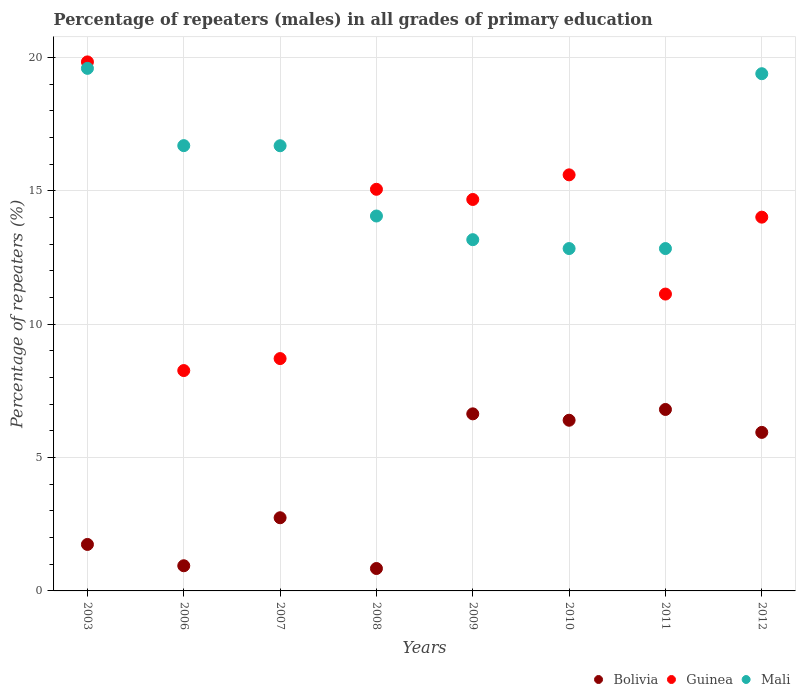Is the number of dotlines equal to the number of legend labels?
Keep it short and to the point. Yes. What is the percentage of repeaters (males) in Mali in 2009?
Offer a terse response. 13.17. Across all years, what is the maximum percentage of repeaters (males) in Guinea?
Make the answer very short. 19.84. Across all years, what is the minimum percentage of repeaters (males) in Guinea?
Give a very brief answer. 8.26. What is the total percentage of repeaters (males) in Bolivia in the graph?
Make the answer very short. 32.06. What is the difference between the percentage of repeaters (males) in Bolivia in 2006 and that in 2008?
Offer a terse response. 0.1. What is the difference between the percentage of repeaters (males) in Guinea in 2007 and the percentage of repeaters (males) in Bolivia in 2010?
Give a very brief answer. 2.31. What is the average percentage of repeaters (males) in Bolivia per year?
Ensure brevity in your answer.  4.01. In the year 2007, what is the difference between the percentage of repeaters (males) in Bolivia and percentage of repeaters (males) in Guinea?
Your answer should be very brief. -5.97. In how many years, is the percentage of repeaters (males) in Bolivia greater than 4 %?
Your response must be concise. 4. What is the ratio of the percentage of repeaters (males) in Guinea in 2007 to that in 2012?
Offer a terse response. 0.62. Is the percentage of repeaters (males) in Guinea in 2009 less than that in 2010?
Ensure brevity in your answer.  Yes. What is the difference between the highest and the second highest percentage of repeaters (males) in Bolivia?
Ensure brevity in your answer.  0.16. What is the difference between the highest and the lowest percentage of repeaters (males) in Bolivia?
Your response must be concise. 5.96. Is the percentage of repeaters (males) in Mali strictly greater than the percentage of repeaters (males) in Bolivia over the years?
Provide a short and direct response. Yes. Is the percentage of repeaters (males) in Mali strictly less than the percentage of repeaters (males) in Guinea over the years?
Give a very brief answer. No. Are the values on the major ticks of Y-axis written in scientific E-notation?
Your response must be concise. No. Does the graph contain grids?
Your answer should be compact. Yes. How many legend labels are there?
Provide a succinct answer. 3. What is the title of the graph?
Provide a short and direct response. Percentage of repeaters (males) in all grades of primary education. Does "Tajikistan" appear as one of the legend labels in the graph?
Keep it short and to the point. No. What is the label or title of the X-axis?
Give a very brief answer. Years. What is the label or title of the Y-axis?
Offer a very short reply. Percentage of repeaters (%). What is the Percentage of repeaters (%) in Bolivia in 2003?
Your answer should be compact. 1.74. What is the Percentage of repeaters (%) in Guinea in 2003?
Ensure brevity in your answer.  19.84. What is the Percentage of repeaters (%) of Mali in 2003?
Provide a short and direct response. 19.59. What is the Percentage of repeaters (%) in Bolivia in 2006?
Give a very brief answer. 0.94. What is the Percentage of repeaters (%) of Guinea in 2006?
Ensure brevity in your answer.  8.26. What is the Percentage of repeaters (%) of Mali in 2006?
Your answer should be very brief. 16.7. What is the Percentage of repeaters (%) in Bolivia in 2007?
Your answer should be compact. 2.74. What is the Percentage of repeaters (%) in Guinea in 2007?
Offer a very short reply. 8.71. What is the Percentage of repeaters (%) of Mali in 2007?
Your answer should be very brief. 16.69. What is the Percentage of repeaters (%) in Bolivia in 2008?
Give a very brief answer. 0.84. What is the Percentage of repeaters (%) of Guinea in 2008?
Your answer should be very brief. 15.06. What is the Percentage of repeaters (%) of Mali in 2008?
Offer a very short reply. 14.06. What is the Percentage of repeaters (%) of Bolivia in 2009?
Keep it short and to the point. 6.64. What is the Percentage of repeaters (%) of Guinea in 2009?
Offer a terse response. 14.68. What is the Percentage of repeaters (%) in Mali in 2009?
Offer a terse response. 13.17. What is the Percentage of repeaters (%) of Bolivia in 2010?
Provide a short and direct response. 6.4. What is the Percentage of repeaters (%) of Guinea in 2010?
Offer a terse response. 15.6. What is the Percentage of repeaters (%) of Mali in 2010?
Provide a short and direct response. 12.84. What is the Percentage of repeaters (%) in Bolivia in 2011?
Your answer should be compact. 6.8. What is the Percentage of repeaters (%) in Guinea in 2011?
Give a very brief answer. 11.13. What is the Percentage of repeaters (%) in Mali in 2011?
Provide a succinct answer. 12.84. What is the Percentage of repeaters (%) of Bolivia in 2012?
Give a very brief answer. 5.94. What is the Percentage of repeaters (%) of Guinea in 2012?
Provide a short and direct response. 14.01. What is the Percentage of repeaters (%) in Mali in 2012?
Provide a short and direct response. 19.39. Across all years, what is the maximum Percentage of repeaters (%) of Bolivia?
Your answer should be very brief. 6.8. Across all years, what is the maximum Percentage of repeaters (%) in Guinea?
Offer a very short reply. 19.84. Across all years, what is the maximum Percentage of repeaters (%) of Mali?
Offer a terse response. 19.59. Across all years, what is the minimum Percentage of repeaters (%) in Bolivia?
Keep it short and to the point. 0.84. Across all years, what is the minimum Percentage of repeaters (%) of Guinea?
Offer a terse response. 8.26. Across all years, what is the minimum Percentage of repeaters (%) of Mali?
Your response must be concise. 12.84. What is the total Percentage of repeaters (%) in Bolivia in the graph?
Your answer should be compact. 32.06. What is the total Percentage of repeaters (%) of Guinea in the graph?
Keep it short and to the point. 107.29. What is the total Percentage of repeaters (%) in Mali in the graph?
Provide a short and direct response. 125.28. What is the difference between the Percentage of repeaters (%) of Bolivia in 2003 and that in 2006?
Your answer should be very brief. 0.8. What is the difference between the Percentage of repeaters (%) of Guinea in 2003 and that in 2006?
Provide a succinct answer. 11.57. What is the difference between the Percentage of repeaters (%) of Mali in 2003 and that in 2006?
Provide a short and direct response. 2.9. What is the difference between the Percentage of repeaters (%) in Bolivia in 2003 and that in 2007?
Your answer should be very brief. -1. What is the difference between the Percentage of repeaters (%) in Guinea in 2003 and that in 2007?
Your answer should be compact. 11.12. What is the difference between the Percentage of repeaters (%) of Mali in 2003 and that in 2007?
Your answer should be very brief. 2.9. What is the difference between the Percentage of repeaters (%) of Bolivia in 2003 and that in 2008?
Ensure brevity in your answer.  0.9. What is the difference between the Percentage of repeaters (%) in Guinea in 2003 and that in 2008?
Offer a terse response. 4.78. What is the difference between the Percentage of repeaters (%) in Mali in 2003 and that in 2008?
Provide a succinct answer. 5.54. What is the difference between the Percentage of repeaters (%) of Bolivia in 2003 and that in 2009?
Your answer should be compact. -4.9. What is the difference between the Percentage of repeaters (%) in Guinea in 2003 and that in 2009?
Your answer should be very brief. 5.16. What is the difference between the Percentage of repeaters (%) of Mali in 2003 and that in 2009?
Ensure brevity in your answer.  6.42. What is the difference between the Percentage of repeaters (%) of Bolivia in 2003 and that in 2010?
Your response must be concise. -4.66. What is the difference between the Percentage of repeaters (%) of Guinea in 2003 and that in 2010?
Provide a succinct answer. 4.23. What is the difference between the Percentage of repeaters (%) of Mali in 2003 and that in 2010?
Your answer should be compact. 6.76. What is the difference between the Percentage of repeaters (%) of Bolivia in 2003 and that in 2011?
Provide a succinct answer. -5.06. What is the difference between the Percentage of repeaters (%) of Guinea in 2003 and that in 2011?
Offer a very short reply. 8.7. What is the difference between the Percentage of repeaters (%) in Mali in 2003 and that in 2011?
Your answer should be very brief. 6.76. What is the difference between the Percentage of repeaters (%) in Bolivia in 2003 and that in 2012?
Make the answer very short. -4.2. What is the difference between the Percentage of repeaters (%) of Guinea in 2003 and that in 2012?
Your response must be concise. 5.82. What is the difference between the Percentage of repeaters (%) of Mali in 2003 and that in 2012?
Your response must be concise. 0.2. What is the difference between the Percentage of repeaters (%) in Bolivia in 2006 and that in 2007?
Make the answer very short. -1.8. What is the difference between the Percentage of repeaters (%) of Guinea in 2006 and that in 2007?
Provide a succinct answer. -0.45. What is the difference between the Percentage of repeaters (%) of Mali in 2006 and that in 2007?
Make the answer very short. 0. What is the difference between the Percentage of repeaters (%) in Bolivia in 2006 and that in 2008?
Ensure brevity in your answer.  0.1. What is the difference between the Percentage of repeaters (%) in Guinea in 2006 and that in 2008?
Provide a succinct answer. -6.8. What is the difference between the Percentage of repeaters (%) in Mali in 2006 and that in 2008?
Your answer should be very brief. 2.64. What is the difference between the Percentage of repeaters (%) in Bolivia in 2006 and that in 2009?
Offer a very short reply. -5.7. What is the difference between the Percentage of repeaters (%) of Guinea in 2006 and that in 2009?
Provide a succinct answer. -6.42. What is the difference between the Percentage of repeaters (%) of Mali in 2006 and that in 2009?
Keep it short and to the point. 3.53. What is the difference between the Percentage of repeaters (%) in Bolivia in 2006 and that in 2010?
Offer a very short reply. -5.46. What is the difference between the Percentage of repeaters (%) in Guinea in 2006 and that in 2010?
Make the answer very short. -7.34. What is the difference between the Percentage of repeaters (%) of Mali in 2006 and that in 2010?
Offer a terse response. 3.86. What is the difference between the Percentage of repeaters (%) in Bolivia in 2006 and that in 2011?
Provide a succinct answer. -5.86. What is the difference between the Percentage of repeaters (%) of Guinea in 2006 and that in 2011?
Give a very brief answer. -2.87. What is the difference between the Percentage of repeaters (%) of Mali in 2006 and that in 2011?
Your answer should be very brief. 3.86. What is the difference between the Percentage of repeaters (%) in Bolivia in 2006 and that in 2012?
Provide a succinct answer. -5. What is the difference between the Percentage of repeaters (%) in Guinea in 2006 and that in 2012?
Ensure brevity in your answer.  -5.75. What is the difference between the Percentage of repeaters (%) in Mali in 2006 and that in 2012?
Make the answer very short. -2.7. What is the difference between the Percentage of repeaters (%) of Bolivia in 2007 and that in 2008?
Your answer should be compact. 1.9. What is the difference between the Percentage of repeaters (%) of Guinea in 2007 and that in 2008?
Keep it short and to the point. -6.35. What is the difference between the Percentage of repeaters (%) of Mali in 2007 and that in 2008?
Your response must be concise. 2.63. What is the difference between the Percentage of repeaters (%) of Bolivia in 2007 and that in 2009?
Keep it short and to the point. -3.9. What is the difference between the Percentage of repeaters (%) of Guinea in 2007 and that in 2009?
Offer a terse response. -5.97. What is the difference between the Percentage of repeaters (%) in Mali in 2007 and that in 2009?
Make the answer very short. 3.52. What is the difference between the Percentage of repeaters (%) in Bolivia in 2007 and that in 2010?
Your answer should be compact. -3.66. What is the difference between the Percentage of repeaters (%) of Guinea in 2007 and that in 2010?
Offer a terse response. -6.89. What is the difference between the Percentage of repeaters (%) in Mali in 2007 and that in 2010?
Offer a very short reply. 3.85. What is the difference between the Percentage of repeaters (%) of Bolivia in 2007 and that in 2011?
Offer a very short reply. -4.06. What is the difference between the Percentage of repeaters (%) of Guinea in 2007 and that in 2011?
Give a very brief answer. -2.42. What is the difference between the Percentage of repeaters (%) in Mali in 2007 and that in 2011?
Offer a terse response. 3.85. What is the difference between the Percentage of repeaters (%) of Bolivia in 2007 and that in 2012?
Provide a succinct answer. -3.2. What is the difference between the Percentage of repeaters (%) of Guinea in 2007 and that in 2012?
Your answer should be very brief. -5.3. What is the difference between the Percentage of repeaters (%) of Mali in 2007 and that in 2012?
Your answer should be very brief. -2.7. What is the difference between the Percentage of repeaters (%) of Bolivia in 2008 and that in 2009?
Offer a very short reply. -5.8. What is the difference between the Percentage of repeaters (%) of Guinea in 2008 and that in 2009?
Keep it short and to the point. 0.38. What is the difference between the Percentage of repeaters (%) of Mali in 2008 and that in 2009?
Your answer should be very brief. 0.89. What is the difference between the Percentage of repeaters (%) in Bolivia in 2008 and that in 2010?
Provide a short and direct response. -5.56. What is the difference between the Percentage of repeaters (%) of Guinea in 2008 and that in 2010?
Give a very brief answer. -0.54. What is the difference between the Percentage of repeaters (%) in Mali in 2008 and that in 2010?
Your answer should be very brief. 1.22. What is the difference between the Percentage of repeaters (%) of Bolivia in 2008 and that in 2011?
Give a very brief answer. -5.96. What is the difference between the Percentage of repeaters (%) of Guinea in 2008 and that in 2011?
Provide a succinct answer. 3.93. What is the difference between the Percentage of repeaters (%) in Mali in 2008 and that in 2011?
Your response must be concise. 1.22. What is the difference between the Percentage of repeaters (%) of Bolivia in 2008 and that in 2012?
Your answer should be compact. -5.1. What is the difference between the Percentage of repeaters (%) of Guinea in 2008 and that in 2012?
Make the answer very short. 1.04. What is the difference between the Percentage of repeaters (%) in Mali in 2008 and that in 2012?
Your answer should be very brief. -5.34. What is the difference between the Percentage of repeaters (%) of Bolivia in 2009 and that in 2010?
Offer a terse response. 0.24. What is the difference between the Percentage of repeaters (%) in Guinea in 2009 and that in 2010?
Offer a very short reply. -0.92. What is the difference between the Percentage of repeaters (%) in Mali in 2009 and that in 2010?
Your answer should be compact. 0.33. What is the difference between the Percentage of repeaters (%) in Bolivia in 2009 and that in 2011?
Ensure brevity in your answer.  -0.16. What is the difference between the Percentage of repeaters (%) of Guinea in 2009 and that in 2011?
Your answer should be compact. 3.55. What is the difference between the Percentage of repeaters (%) in Mali in 2009 and that in 2011?
Keep it short and to the point. 0.33. What is the difference between the Percentage of repeaters (%) of Bolivia in 2009 and that in 2012?
Ensure brevity in your answer.  0.7. What is the difference between the Percentage of repeaters (%) of Guinea in 2009 and that in 2012?
Your response must be concise. 0.66. What is the difference between the Percentage of repeaters (%) of Mali in 2009 and that in 2012?
Offer a terse response. -6.22. What is the difference between the Percentage of repeaters (%) of Bolivia in 2010 and that in 2011?
Give a very brief answer. -0.4. What is the difference between the Percentage of repeaters (%) of Guinea in 2010 and that in 2011?
Offer a terse response. 4.47. What is the difference between the Percentage of repeaters (%) of Bolivia in 2010 and that in 2012?
Your response must be concise. 0.46. What is the difference between the Percentage of repeaters (%) of Guinea in 2010 and that in 2012?
Give a very brief answer. 1.59. What is the difference between the Percentage of repeaters (%) of Mali in 2010 and that in 2012?
Give a very brief answer. -6.56. What is the difference between the Percentage of repeaters (%) in Bolivia in 2011 and that in 2012?
Ensure brevity in your answer.  0.86. What is the difference between the Percentage of repeaters (%) in Guinea in 2011 and that in 2012?
Your response must be concise. -2.88. What is the difference between the Percentage of repeaters (%) in Mali in 2011 and that in 2012?
Keep it short and to the point. -6.56. What is the difference between the Percentage of repeaters (%) in Bolivia in 2003 and the Percentage of repeaters (%) in Guinea in 2006?
Your answer should be very brief. -6.52. What is the difference between the Percentage of repeaters (%) in Bolivia in 2003 and the Percentage of repeaters (%) in Mali in 2006?
Provide a short and direct response. -14.95. What is the difference between the Percentage of repeaters (%) of Guinea in 2003 and the Percentage of repeaters (%) of Mali in 2006?
Your response must be concise. 3.14. What is the difference between the Percentage of repeaters (%) of Bolivia in 2003 and the Percentage of repeaters (%) of Guinea in 2007?
Provide a succinct answer. -6.97. What is the difference between the Percentage of repeaters (%) of Bolivia in 2003 and the Percentage of repeaters (%) of Mali in 2007?
Provide a succinct answer. -14.95. What is the difference between the Percentage of repeaters (%) in Guinea in 2003 and the Percentage of repeaters (%) in Mali in 2007?
Make the answer very short. 3.14. What is the difference between the Percentage of repeaters (%) in Bolivia in 2003 and the Percentage of repeaters (%) in Guinea in 2008?
Provide a short and direct response. -13.32. What is the difference between the Percentage of repeaters (%) of Bolivia in 2003 and the Percentage of repeaters (%) of Mali in 2008?
Your answer should be compact. -12.31. What is the difference between the Percentage of repeaters (%) in Guinea in 2003 and the Percentage of repeaters (%) in Mali in 2008?
Your answer should be compact. 5.78. What is the difference between the Percentage of repeaters (%) in Bolivia in 2003 and the Percentage of repeaters (%) in Guinea in 2009?
Give a very brief answer. -12.93. What is the difference between the Percentage of repeaters (%) in Bolivia in 2003 and the Percentage of repeaters (%) in Mali in 2009?
Provide a short and direct response. -11.43. What is the difference between the Percentage of repeaters (%) in Guinea in 2003 and the Percentage of repeaters (%) in Mali in 2009?
Your response must be concise. 6.67. What is the difference between the Percentage of repeaters (%) of Bolivia in 2003 and the Percentage of repeaters (%) of Guinea in 2010?
Your response must be concise. -13.86. What is the difference between the Percentage of repeaters (%) in Bolivia in 2003 and the Percentage of repeaters (%) in Mali in 2010?
Keep it short and to the point. -11.09. What is the difference between the Percentage of repeaters (%) of Guinea in 2003 and the Percentage of repeaters (%) of Mali in 2010?
Give a very brief answer. 7. What is the difference between the Percentage of repeaters (%) in Bolivia in 2003 and the Percentage of repeaters (%) in Guinea in 2011?
Your answer should be very brief. -9.39. What is the difference between the Percentage of repeaters (%) in Bolivia in 2003 and the Percentage of repeaters (%) in Mali in 2011?
Make the answer very short. -11.09. What is the difference between the Percentage of repeaters (%) of Guinea in 2003 and the Percentage of repeaters (%) of Mali in 2011?
Provide a short and direct response. 7. What is the difference between the Percentage of repeaters (%) of Bolivia in 2003 and the Percentage of repeaters (%) of Guinea in 2012?
Offer a terse response. -12.27. What is the difference between the Percentage of repeaters (%) of Bolivia in 2003 and the Percentage of repeaters (%) of Mali in 2012?
Offer a terse response. -17.65. What is the difference between the Percentage of repeaters (%) of Guinea in 2003 and the Percentage of repeaters (%) of Mali in 2012?
Give a very brief answer. 0.44. What is the difference between the Percentage of repeaters (%) of Bolivia in 2006 and the Percentage of repeaters (%) of Guinea in 2007?
Your answer should be very brief. -7.77. What is the difference between the Percentage of repeaters (%) of Bolivia in 2006 and the Percentage of repeaters (%) of Mali in 2007?
Your response must be concise. -15.75. What is the difference between the Percentage of repeaters (%) in Guinea in 2006 and the Percentage of repeaters (%) in Mali in 2007?
Ensure brevity in your answer.  -8.43. What is the difference between the Percentage of repeaters (%) of Bolivia in 2006 and the Percentage of repeaters (%) of Guinea in 2008?
Keep it short and to the point. -14.12. What is the difference between the Percentage of repeaters (%) in Bolivia in 2006 and the Percentage of repeaters (%) in Mali in 2008?
Give a very brief answer. -13.11. What is the difference between the Percentage of repeaters (%) in Guinea in 2006 and the Percentage of repeaters (%) in Mali in 2008?
Make the answer very short. -5.8. What is the difference between the Percentage of repeaters (%) of Bolivia in 2006 and the Percentage of repeaters (%) of Guinea in 2009?
Provide a succinct answer. -13.73. What is the difference between the Percentage of repeaters (%) in Bolivia in 2006 and the Percentage of repeaters (%) in Mali in 2009?
Ensure brevity in your answer.  -12.23. What is the difference between the Percentage of repeaters (%) in Guinea in 2006 and the Percentage of repeaters (%) in Mali in 2009?
Give a very brief answer. -4.91. What is the difference between the Percentage of repeaters (%) in Bolivia in 2006 and the Percentage of repeaters (%) in Guinea in 2010?
Your answer should be very brief. -14.66. What is the difference between the Percentage of repeaters (%) in Bolivia in 2006 and the Percentage of repeaters (%) in Mali in 2010?
Your answer should be very brief. -11.89. What is the difference between the Percentage of repeaters (%) of Guinea in 2006 and the Percentage of repeaters (%) of Mali in 2010?
Provide a succinct answer. -4.57. What is the difference between the Percentage of repeaters (%) in Bolivia in 2006 and the Percentage of repeaters (%) in Guinea in 2011?
Your response must be concise. -10.19. What is the difference between the Percentage of repeaters (%) in Bolivia in 2006 and the Percentage of repeaters (%) in Mali in 2011?
Provide a short and direct response. -11.89. What is the difference between the Percentage of repeaters (%) in Guinea in 2006 and the Percentage of repeaters (%) in Mali in 2011?
Provide a short and direct response. -4.57. What is the difference between the Percentage of repeaters (%) of Bolivia in 2006 and the Percentage of repeaters (%) of Guinea in 2012?
Ensure brevity in your answer.  -13.07. What is the difference between the Percentage of repeaters (%) of Bolivia in 2006 and the Percentage of repeaters (%) of Mali in 2012?
Give a very brief answer. -18.45. What is the difference between the Percentage of repeaters (%) of Guinea in 2006 and the Percentage of repeaters (%) of Mali in 2012?
Your answer should be compact. -11.13. What is the difference between the Percentage of repeaters (%) of Bolivia in 2007 and the Percentage of repeaters (%) of Guinea in 2008?
Provide a succinct answer. -12.32. What is the difference between the Percentage of repeaters (%) of Bolivia in 2007 and the Percentage of repeaters (%) of Mali in 2008?
Provide a succinct answer. -11.31. What is the difference between the Percentage of repeaters (%) in Guinea in 2007 and the Percentage of repeaters (%) in Mali in 2008?
Your answer should be very brief. -5.35. What is the difference between the Percentage of repeaters (%) of Bolivia in 2007 and the Percentage of repeaters (%) of Guinea in 2009?
Give a very brief answer. -11.93. What is the difference between the Percentage of repeaters (%) of Bolivia in 2007 and the Percentage of repeaters (%) of Mali in 2009?
Offer a very short reply. -10.43. What is the difference between the Percentage of repeaters (%) of Guinea in 2007 and the Percentage of repeaters (%) of Mali in 2009?
Make the answer very short. -4.46. What is the difference between the Percentage of repeaters (%) in Bolivia in 2007 and the Percentage of repeaters (%) in Guinea in 2010?
Give a very brief answer. -12.86. What is the difference between the Percentage of repeaters (%) in Bolivia in 2007 and the Percentage of repeaters (%) in Mali in 2010?
Make the answer very short. -10.09. What is the difference between the Percentage of repeaters (%) of Guinea in 2007 and the Percentage of repeaters (%) of Mali in 2010?
Your answer should be very brief. -4.13. What is the difference between the Percentage of repeaters (%) of Bolivia in 2007 and the Percentage of repeaters (%) of Guinea in 2011?
Provide a short and direct response. -8.39. What is the difference between the Percentage of repeaters (%) of Bolivia in 2007 and the Percentage of repeaters (%) of Mali in 2011?
Ensure brevity in your answer.  -10.09. What is the difference between the Percentage of repeaters (%) of Guinea in 2007 and the Percentage of repeaters (%) of Mali in 2011?
Offer a terse response. -4.13. What is the difference between the Percentage of repeaters (%) in Bolivia in 2007 and the Percentage of repeaters (%) in Guinea in 2012?
Ensure brevity in your answer.  -11.27. What is the difference between the Percentage of repeaters (%) in Bolivia in 2007 and the Percentage of repeaters (%) in Mali in 2012?
Offer a terse response. -16.65. What is the difference between the Percentage of repeaters (%) of Guinea in 2007 and the Percentage of repeaters (%) of Mali in 2012?
Offer a terse response. -10.68. What is the difference between the Percentage of repeaters (%) in Bolivia in 2008 and the Percentage of repeaters (%) in Guinea in 2009?
Provide a short and direct response. -13.84. What is the difference between the Percentage of repeaters (%) of Bolivia in 2008 and the Percentage of repeaters (%) of Mali in 2009?
Give a very brief answer. -12.33. What is the difference between the Percentage of repeaters (%) of Guinea in 2008 and the Percentage of repeaters (%) of Mali in 2009?
Give a very brief answer. 1.89. What is the difference between the Percentage of repeaters (%) of Bolivia in 2008 and the Percentage of repeaters (%) of Guinea in 2010?
Offer a very short reply. -14.76. What is the difference between the Percentage of repeaters (%) in Bolivia in 2008 and the Percentage of repeaters (%) in Mali in 2010?
Make the answer very short. -12. What is the difference between the Percentage of repeaters (%) of Guinea in 2008 and the Percentage of repeaters (%) of Mali in 2010?
Ensure brevity in your answer.  2.22. What is the difference between the Percentage of repeaters (%) of Bolivia in 2008 and the Percentage of repeaters (%) of Guinea in 2011?
Keep it short and to the point. -10.29. What is the difference between the Percentage of repeaters (%) of Bolivia in 2008 and the Percentage of repeaters (%) of Mali in 2011?
Make the answer very short. -12. What is the difference between the Percentage of repeaters (%) in Guinea in 2008 and the Percentage of repeaters (%) in Mali in 2011?
Ensure brevity in your answer.  2.22. What is the difference between the Percentage of repeaters (%) of Bolivia in 2008 and the Percentage of repeaters (%) of Guinea in 2012?
Keep it short and to the point. -13.17. What is the difference between the Percentage of repeaters (%) of Bolivia in 2008 and the Percentage of repeaters (%) of Mali in 2012?
Offer a terse response. -18.55. What is the difference between the Percentage of repeaters (%) in Guinea in 2008 and the Percentage of repeaters (%) in Mali in 2012?
Give a very brief answer. -4.33. What is the difference between the Percentage of repeaters (%) in Bolivia in 2009 and the Percentage of repeaters (%) in Guinea in 2010?
Provide a short and direct response. -8.96. What is the difference between the Percentage of repeaters (%) in Bolivia in 2009 and the Percentage of repeaters (%) in Mali in 2010?
Provide a short and direct response. -6.2. What is the difference between the Percentage of repeaters (%) in Guinea in 2009 and the Percentage of repeaters (%) in Mali in 2010?
Provide a short and direct response. 1.84. What is the difference between the Percentage of repeaters (%) in Bolivia in 2009 and the Percentage of repeaters (%) in Guinea in 2011?
Your answer should be very brief. -4.49. What is the difference between the Percentage of repeaters (%) of Bolivia in 2009 and the Percentage of repeaters (%) of Mali in 2011?
Keep it short and to the point. -6.2. What is the difference between the Percentage of repeaters (%) in Guinea in 2009 and the Percentage of repeaters (%) in Mali in 2011?
Give a very brief answer. 1.84. What is the difference between the Percentage of repeaters (%) of Bolivia in 2009 and the Percentage of repeaters (%) of Guinea in 2012?
Offer a very short reply. -7.38. What is the difference between the Percentage of repeaters (%) in Bolivia in 2009 and the Percentage of repeaters (%) in Mali in 2012?
Provide a succinct answer. -12.75. What is the difference between the Percentage of repeaters (%) in Guinea in 2009 and the Percentage of repeaters (%) in Mali in 2012?
Make the answer very short. -4.72. What is the difference between the Percentage of repeaters (%) in Bolivia in 2010 and the Percentage of repeaters (%) in Guinea in 2011?
Give a very brief answer. -4.73. What is the difference between the Percentage of repeaters (%) in Bolivia in 2010 and the Percentage of repeaters (%) in Mali in 2011?
Offer a very short reply. -6.44. What is the difference between the Percentage of repeaters (%) in Guinea in 2010 and the Percentage of repeaters (%) in Mali in 2011?
Offer a terse response. 2.76. What is the difference between the Percentage of repeaters (%) of Bolivia in 2010 and the Percentage of repeaters (%) of Guinea in 2012?
Ensure brevity in your answer.  -7.61. What is the difference between the Percentage of repeaters (%) in Bolivia in 2010 and the Percentage of repeaters (%) in Mali in 2012?
Your response must be concise. -12.99. What is the difference between the Percentage of repeaters (%) of Guinea in 2010 and the Percentage of repeaters (%) of Mali in 2012?
Keep it short and to the point. -3.79. What is the difference between the Percentage of repeaters (%) of Bolivia in 2011 and the Percentage of repeaters (%) of Guinea in 2012?
Keep it short and to the point. -7.21. What is the difference between the Percentage of repeaters (%) of Bolivia in 2011 and the Percentage of repeaters (%) of Mali in 2012?
Offer a terse response. -12.59. What is the difference between the Percentage of repeaters (%) of Guinea in 2011 and the Percentage of repeaters (%) of Mali in 2012?
Your response must be concise. -8.26. What is the average Percentage of repeaters (%) of Bolivia per year?
Your response must be concise. 4.01. What is the average Percentage of repeaters (%) of Guinea per year?
Offer a terse response. 13.41. What is the average Percentage of repeaters (%) in Mali per year?
Provide a succinct answer. 15.66. In the year 2003, what is the difference between the Percentage of repeaters (%) of Bolivia and Percentage of repeaters (%) of Guinea?
Your answer should be very brief. -18.09. In the year 2003, what is the difference between the Percentage of repeaters (%) of Bolivia and Percentage of repeaters (%) of Mali?
Your answer should be very brief. -17.85. In the year 2003, what is the difference between the Percentage of repeaters (%) of Guinea and Percentage of repeaters (%) of Mali?
Your response must be concise. 0.24. In the year 2006, what is the difference between the Percentage of repeaters (%) of Bolivia and Percentage of repeaters (%) of Guinea?
Keep it short and to the point. -7.32. In the year 2006, what is the difference between the Percentage of repeaters (%) of Bolivia and Percentage of repeaters (%) of Mali?
Provide a succinct answer. -15.75. In the year 2006, what is the difference between the Percentage of repeaters (%) in Guinea and Percentage of repeaters (%) in Mali?
Offer a very short reply. -8.43. In the year 2007, what is the difference between the Percentage of repeaters (%) in Bolivia and Percentage of repeaters (%) in Guinea?
Offer a terse response. -5.97. In the year 2007, what is the difference between the Percentage of repeaters (%) in Bolivia and Percentage of repeaters (%) in Mali?
Give a very brief answer. -13.95. In the year 2007, what is the difference between the Percentage of repeaters (%) in Guinea and Percentage of repeaters (%) in Mali?
Your answer should be very brief. -7.98. In the year 2008, what is the difference between the Percentage of repeaters (%) in Bolivia and Percentage of repeaters (%) in Guinea?
Give a very brief answer. -14.22. In the year 2008, what is the difference between the Percentage of repeaters (%) in Bolivia and Percentage of repeaters (%) in Mali?
Provide a succinct answer. -13.22. In the year 2008, what is the difference between the Percentage of repeaters (%) of Guinea and Percentage of repeaters (%) of Mali?
Your response must be concise. 1. In the year 2009, what is the difference between the Percentage of repeaters (%) in Bolivia and Percentage of repeaters (%) in Guinea?
Offer a terse response. -8.04. In the year 2009, what is the difference between the Percentage of repeaters (%) of Bolivia and Percentage of repeaters (%) of Mali?
Keep it short and to the point. -6.53. In the year 2009, what is the difference between the Percentage of repeaters (%) of Guinea and Percentage of repeaters (%) of Mali?
Offer a very short reply. 1.51. In the year 2010, what is the difference between the Percentage of repeaters (%) in Bolivia and Percentage of repeaters (%) in Guinea?
Your answer should be very brief. -9.2. In the year 2010, what is the difference between the Percentage of repeaters (%) of Bolivia and Percentage of repeaters (%) of Mali?
Your answer should be compact. -6.44. In the year 2010, what is the difference between the Percentage of repeaters (%) of Guinea and Percentage of repeaters (%) of Mali?
Give a very brief answer. 2.76. In the year 2011, what is the difference between the Percentage of repeaters (%) of Bolivia and Percentage of repeaters (%) of Guinea?
Give a very brief answer. -4.33. In the year 2011, what is the difference between the Percentage of repeaters (%) in Bolivia and Percentage of repeaters (%) in Mali?
Offer a terse response. -6.03. In the year 2011, what is the difference between the Percentage of repeaters (%) in Guinea and Percentage of repeaters (%) in Mali?
Ensure brevity in your answer.  -1.71. In the year 2012, what is the difference between the Percentage of repeaters (%) in Bolivia and Percentage of repeaters (%) in Guinea?
Offer a terse response. -8.07. In the year 2012, what is the difference between the Percentage of repeaters (%) of Bolivia and Percentage of repeaters (%) of Mali?
Provide a short and direct response. -13.45. In the year 2012, what is the difference between the Percentage of repeaters (%) of Guinea and Percentage of repeaters (%) of Mali?
Your answer should be very brief. -5.38. What is the ratio of the Percentage of repeaters (%) of Bolivia in 2003 to that in 2006?
Ensure brevity in your answer.  1.85. What is the ratio of the Percentage of repeaters (%) in Guinea in 2003 to that in 2006?
Your answer should be very brief. 2.4. What is the ratio of the Percentage of repeaters (%) in Mali in 2003 to that in 2006?
Your answer should be compact. 1.17. What is the ratio of the Percentage of repeaters (%) in Bolivia in 2003 to that in 2007?
Offer a very short reply. 0.64. What is the ratio of the Percentage of repeaters (%) in Guinea in 2003 to that in 2007?
Keep it short and to the point. 2.28. What is the ratio of the Percentage of repeaters (%) of Mali in 2003 to that in 2007?
Offer a terse response. 1.17. What is the ratio of the Percentage of repeaters (%) in Bolivia in 2003 to that in 2008?
Your answer should be very brief. 2.07. What is the ratio of the Percentage of repeaters (%) in Guinea in 2003 to that in 2008?
Your answer should be very brief. 1.32. What is the ratio of the Percentage of repeaters (%) in Mali in 2003 to that in 2008?
Your answer should be compact. 1.39. What is the ratio of the Percentage of repeaters (%) of Bolivia in 2003 to that in 2009?
Provide a short and direct response. 0.26. What is the ratio of the Percentage of repeaters (%) of Guinea in 2003 to that in 2009?
Keep it short and to the point. 1.35. What is the ratio of the Percentage of repeaters (%) of Mali in 2003 to that in 2009?
Make the answer very short. 1.49. What is the ratio of the Percentage of repeaters (%) of Bolivia in 2003 to that in 2010?
Ensure brevity in your answer.  0.27. What is the ratio of the Percentage of repeaters (%) in Guinea in 2003 to that in 2010?
Make the answer very short. 1.27. What is the ratio of the Percentage of repeaters (%) in Mali in 2003 to that in 2010?
Your answer should be compact. 1.53. What is the ratio of the Percentage of repeaters (%) of Bolivia in 2003 to that in 2011?
Ensure brevity in your answer.  0.26. What is the ratio of the Percentage of repeaters (%) of Guinea in 2003 to that in 2011?
Your answer should be compact. 1.78. What is the ratio of the Percentage of repeaters (%) in Mali in 2003 to that in 2011?
Your response must be concise. 1.53. What is the ratio of the Percentage of repeaters (%) of Bolivia in 2003 to that in 2012?
Provide a short and direct response. 0.29. What is the ratio of the Percentage of repeaters (%) in Guinea in 2003 to that in 2012?
Your answer should be compact. 1.42. What is the ratio of the Percentage of repeaters (%) in Mali in 2003 to that in 2012?
Ensure brevity in your answer.  1.01. What is the ratio of the Percentage of repeaters (%) in Bolivia in 2006 to that in 2007?
Provide a succinct answer. 0.34. What is the ratio of the Percentage of repeaters (%) of Guinea in 2006 to that in 2007?
Keep it short and to the point. 0.95. What is the ratio of the Percentage of repeaters (%) of Bolivia in 2006 to that in 2008?
Keep it short and to the point. 1.12. What is the ratio of the Percentage of repeaters (%) in Guinea in 2006 to that in 2008?
Keep it short and to the point. 0.55. What is the ratio of the Percentage of repeaters (%) in Mali in 2006 to that in 2008?
Your response must be concise. 1.19. What is the ratio of the Percentage of repeaters (%) of Bolivia in 2006 to that in 2009?
Provide a succinct answer. 0.14. What is the ratio of the Percentage of repeaters (%) in Guinea in 2006 to that in 2009?
Your answer should be compact. 0.56. What is the ratio of the Percentage of repeaters (%) in Mali in 2006 to that in 2009?
Offer a very short reply. 1.27. What is the ratio of the Percentage of repeaters (%) in Bolivia in 2006 to that in 2010?
Make the answer very short. 0.15. What is the ratio of the Percentage of repeaters (%) of Guinea in 2006 to that in 2010?
Provide a short and direct response. 0.53. What is the ratio of the Percentage of repeaters (%) of Mali in 2006 to that in 2010?
Make the answer very short. 1.3. What is the ratio of the Percentage of repeaters (%) in Bolivia in 2006 to that in 2011?
Offer a very short reply. 0.14. What is the ratio of the Percentage of repeaters (%) in Guinea in 2006 to that in 2011?
Your answer should be compact. 0.74. What is the ratio of the Percentage of repeaters (%) in Mali in 2006 to that in 2011?
Ensure brevity in your answer.  1.3. What is the ratio of the Percentage of repeaters (%) in Bolivia in 2006 to that in 2012?
Offer a terse response. 0.16. What is the ratio of the Percentage of repeaters (%) in Guinea in 2006 to that in 2012?
Offer a terse response. 0.59. What is the ratio of the Percentage of repeaters (%) in Mali in 2006 to that in 2012?
Offer a very short reply. 0.86. What is the ratio of the Percentage of repeaters (%) in Bolivia in 2007 to that in 2008?
Keep it short and to the point. 3.26. What is the ratio of the Percentage of repeaters (%) of Guinea in 2007 to that in 2008?
Your response must be concise. 0.58. What is the ratio of the Percentage of repeaters (%) of Mali in 2007 to that in 2008?
Your answer should be very brief. 1.19. What is the ratio of the Percentage of repeaters (%) in Bolivia in 2007 to that in 2009?
Make the answer very short. 0.41. What is the ratio of the Percentage of repeaters (%) in Guinea in 2007 to that in 2009?
Give a very brief answer. 0.59. What is the ratio of the Percentage of repeaters (%) in Mali in 2007 to that in 2009?
Your response must be concise. 1.27. What is the ratio of the Percentage of repeaters (%) in Bolivia in 2007 to that in 2010?
Offer a terse response. 0.43. What is the ratio of the Percentage of repeaters (%) of Guinea in 2007 to that in 2010?
Keep it short and to the point. 0.56. What is the ratio of the Percentage of repeaters (%) in Mali in 2007 to that in 2010?
Ensure brevity in your answer.  1.3. What is the ratio of the Percentage of repeaters (%) of Bolivia in 2007 to that in 2011?
Offer a very short reply. 0.4. What is the ratio of the Percentage of repeaters (%) of Guinea in 2007 to that in 2011?
Ensure brevity in your answer.  0.78. What is the ratio of the Percentage of repeaters (%) in Mali in 2007 to that in 2011?
Offer a very short reply. 1.3. What is the ratio of the Percentage of repeaters (%) of Bolivia in 2007 to that in 2012?
Your answer should be compact. 0.46. What is the ratio of the Percentage of repeaters (%) in Guinea in 2007 to that in 2012?
Offer a very short reply. 0.62. What is the ratio of the Percentage of repeaters (%) in Mali in 2007 to that in 2012?
Keep it short and to the point. 0.86. What is the ratio of the Percentage of repeaters (%) in Bolivia in 2008 to that in 2009?
Offer a very short reply. 0.13. What is the ratio of the Percentage of repeaters (%) of Guinea in 2008 to that in 2009?
Offer a very short reply. 1.03. What is the ratio of the Percentage of repeaters (%) in Mali in 2008 to that in 2009?
Give a very brief answer. 1.07. What is the ratio of the Percentage of repeaters (%) of Bolivia in 2008 to that in 2010?
Make the answer very short. 0.13. What is the ratio of the Percentage of repeaters (%) in Guinea in 2008 to that in 2010?
Make the answer very short. 0.97. What is the ratio of the Percentage of repeaters (%) of Mali in 2008 to that in 2010?
Keep it short and to the point. 1.1. What is the ratio of the Percentage of repeaters (%) in Bolivia in 2008 to that in 2011?
Provide a short and direct response. 0.12. What is the ratio of the Percentage of repeaters (%) of Guinea in 2008 to that in 2011?
Provide a short and direct response. 1.35. What is the ratio of the Percentage of repeaters (%) of Mali in 2008 to that in 2011?
Ensure brevity in your answer.  1.1. What is the ratio of the Percentage of repeaters (%) in Bolivia in 2008 to that in 2012?
Make the answer very short. 0.14. What is the ratio of the Percentage of repeaters (%) in Guinea in 2008 to that in 2012?
Ensure brevity in your answer.  1.07. What is the ratio of the Percentage of repeaters (%) in Mali in 2008 to that in 2012?
Your answer should be very brief. 0.72. What is the ratio of the Percentage of repeaters (%) in Bolivia in 2009 to that in 2010?
Provide a short and direct response. 1.04. What is the ratio of the Percentage of repeaters (%) of Guinea in 2009 to that in 2010?
Ensure brevity in your answer.  0.94. What is the ratio of the Percentage of repeaters (%) in Mali in 2009 to that in 2010?
Offer a very short reply. 1.03. What is the ratio of the Percentage of repeaters (%) of Bolivia in 2009 to that in 2011?
Offer a terse response. 0.98. What is the ratio of the Percentage of repeaters (%) in Guinea in 2009 to that in 2011?
Provide a succinct answer. 1.32. What is the ratio of the Percentage of repeaters (%) of Mali in 2009 to that in 2011?
Make the answer very short. 1.03. What is the ratio of the Percentage of repeaters (%) of Bolivia in 2009 to that in 2012?
Your response must be concise. 1.12. What is the ratio of the Percentage of repeaters (%) of Guinea in 2009 to that in 2012?
Your answer should be compact. 1.05. What is the ratio of the Percentage of repeaters (%) in Mali in 2009 to that in 2012?
Make the answer very short. 0.68. What is the ratio of the Percentage of repeaters (%) of Bolivia in 2010 to that in 2011?
Keep it short and to the point. 0.94. What is the ratio of the Percentage of repeaters (%) in Guinea in 2010 to that in 2011?
Keep it short and to the point. 1.4. What is the ratio of the Percentage of repeaters (%) in Bolivia in 2010 to that in 2012?
Offer a very short reply. 1.08. What is the ratio of the Percentage of repeaters (%) of Guinea in 2010 to that in 2012?
Your answer should be compact. 1.11. What is the ratio of the Percentage of repeaters (%) of Mali in 2010 to that in 2012?
Ensure brevity in your answer.  0.66. What is the ratio of the Percentage of repeaters (%) in Bolivia in 2011 to that in 2012?
Provide a short and direct response. 1.14. What is the ratio of the Percentage of repeaters (%) of Guinea in 2011 to that in 2012?
Your response must be concise. 0.79. What is the ratio of the Percentage of repeaters (%) of Mali in 2011 to that in 2012?
Offer a very short reply. 0.66. What is the difference between the highest and the second highest Percentage of repeaters (%) in Bolivia?
Your answer should be very brief. 0.16. What is the difference between the highest and the second highest Percentage of repeaters (%) in Guinea?
Your answer should be compact. 4.23. What is the difference between the highest and the second highest Percentage of repeaters (%) in Mali?
Make the answer very short. 0.2. What is the difference between the highest and the lowest Percentage of repeaters (%) of Bolivia?
Offer a terse response. 5.96. What is the difference between the highest and the lowest Percentage of repeaters (%) in Guinea?
Your answer should be very brief. 11.57. What is the difference between the highest and the lowest Percentage of repeaters (%) of Mali?
Your answer should be very brief. 6.76. 